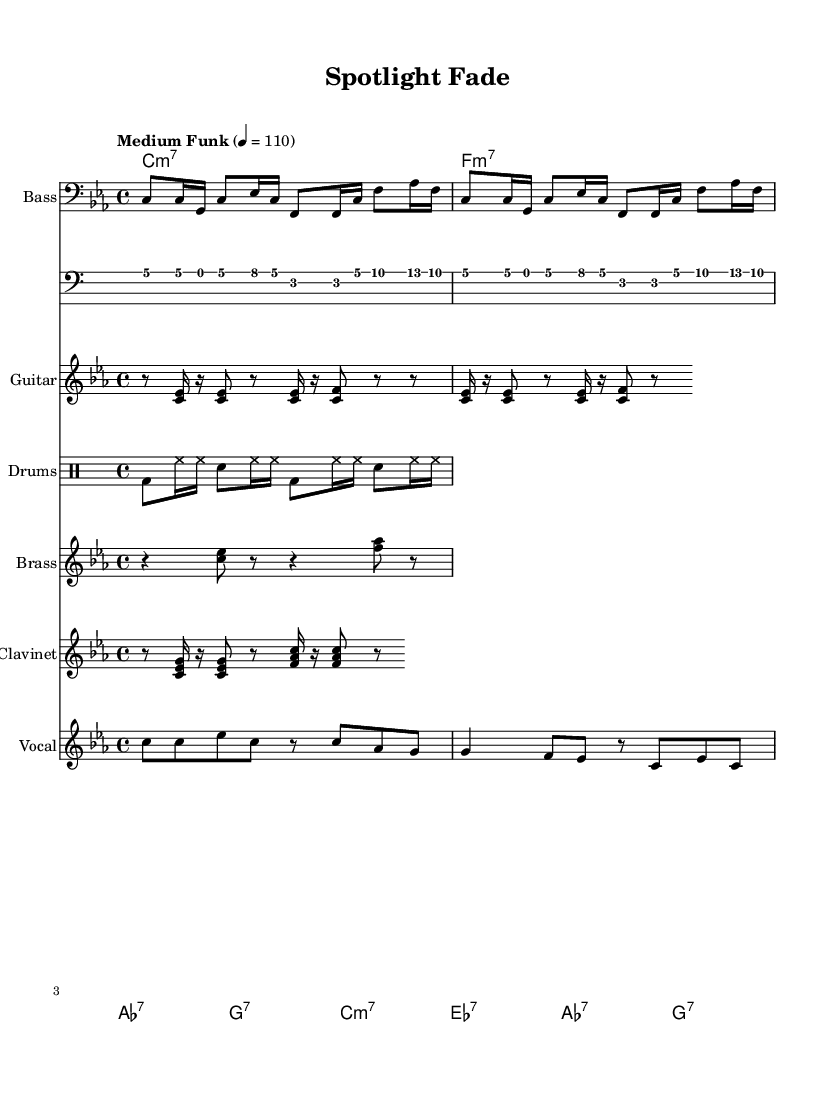What is the key signature of this music? The key signature indicated at the beginning of the score is C minor, which has three flats: B-flat, E-flat, and A-flat.
Answer: C minor What is the time signature of this piece? The time signature shown in the score is 4/4, meaning there are four beats in each measure and the quarter note gets one beat.
Answer: 4/4 What is the tempo of this song? The tempo marking is “Medium Funk” at a speed of quarter note equals 110 beats per minute, indicating a moderate pace typical of funk music.
Answer: Medium Funk 4 = 110 How many measures are in the verse section? Instead of counting through the entire score, we can see that the verse section has a certain chord progression and is repeated twice. Each line in the melody corresponds to the verse, giving us a total of four measures before transitioning to the chorus.
Answer: 4 What instruments are used in this piece? Looking through the score, there is a bass, guitar, drums, brass section, clavinet, and vocals indicated, making it a rich ensemble typical for funk music.
Answer: Bass, Guitar, Drums, Brass, Clavinet, Vocals Which chords are used in the chorus? The chorus contains a progression of chords that includes C minor 7, E-flat 7, A-flat 7, and G7. This harmonic content supports the funk genre and provides a groove-based foundation for the melody.
Answer: C minor 7, E-flat 7, A-flat 7, G7 What lyrical theme does the song evoke? The lyrics suggest a theme of resilience in the face of fading fame, encapsulated in lines reflecting on dimming lights and the struggle to remain relevant. This mirrors the challenges faced within the music industry as indicated by the title "Spotlight Fade."
Answer: Struggles of maintaining relevance 